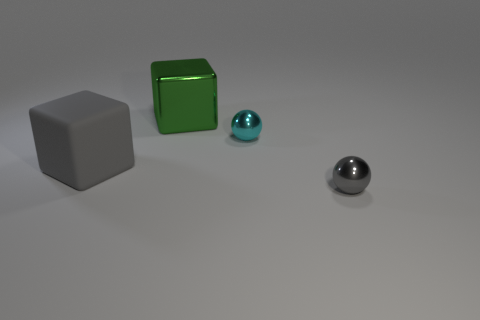Add 2 red metallic things. How many objects exist? 6 Subtract all small blue matte blocks. Subtract all gray metal things. How many objects are left? 3 Add 2 gray matte objects. How many gray matte objects are left? 3 Add 3 large gray rubber blocks. How many large gray rubber blocks exist? 4 Subtract 1 cyan balls. How many objects are left? 3 